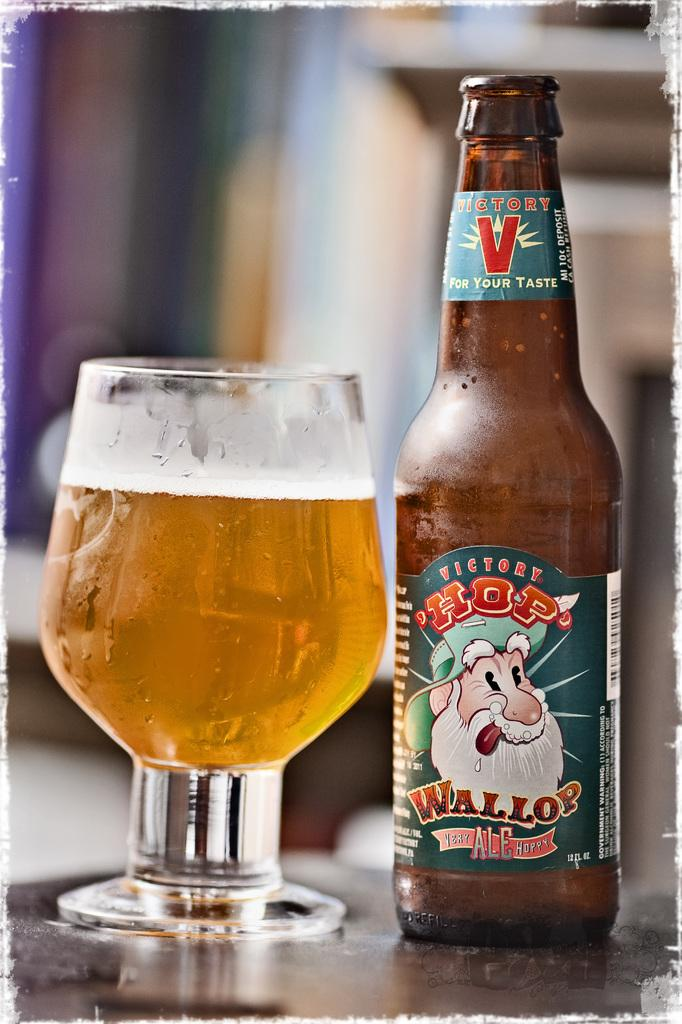<image>
Share a concise interpretation of the image provided. HOP Wollop ale is poured into a nice glass. 